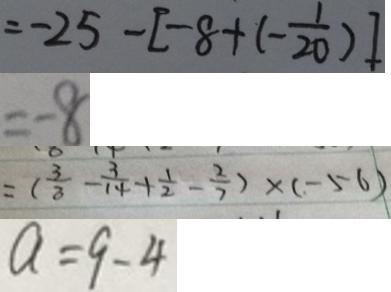Convert formula to latex. <formula><loc_0><loc_0><loc_500><loc_500>= - 2 5 - [ - 8 + ( - \frac { 1 } { 2 0 } ) ] 
 = - 8 
 = ( \frac { 3 } { 3 } - \frac { 3 } { 1 4 } + \frac { 1 } { 2 } - \frac { 2 } { 7 } ) \times ( - 5 6 ) 
 a = 9 - 4</formula> 